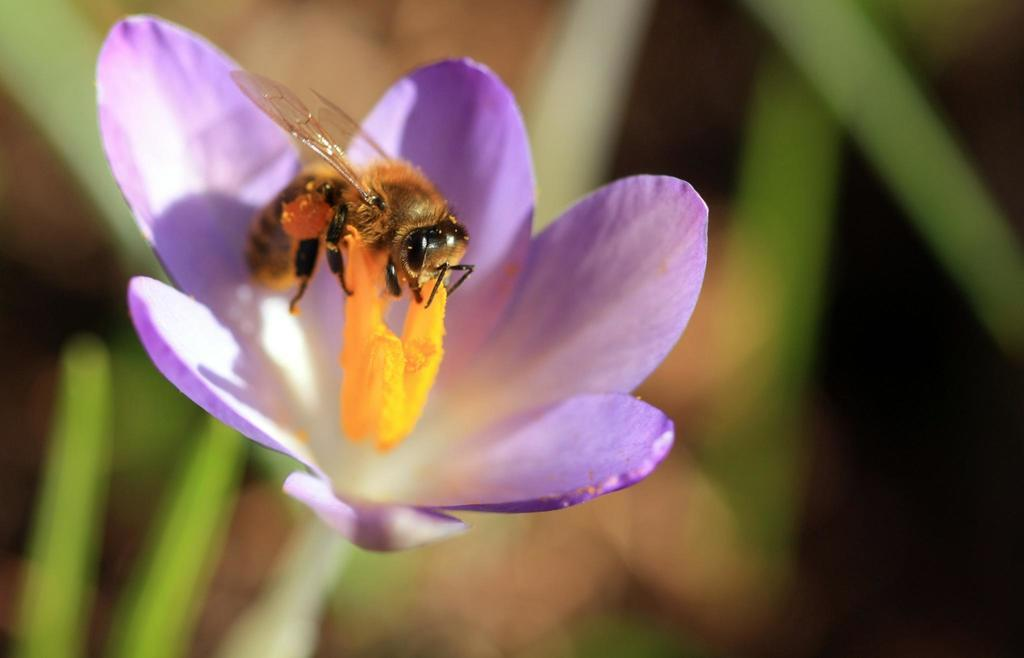What is on the flower in the image? There is an insect on the flower in the image. What is the insect sitting on? The insect is sitting on a flower, which is part of a plant. How would you describe the background of the image? The background is blurred in the image. What type of insurance policy is being discussed in the image? There is no discussion of insurance policies in the image; it features an insect on a flower with a blurred background. 